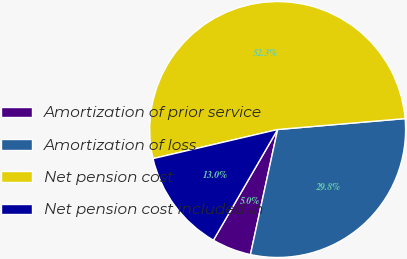<chart> <loc_0><loc_0><loc_500><loc_500><pie_chart><fcel>Amortization of prior service<fcel>Amortization of loss<fcel>Net pension cost<fcel>Net pension cost included in<nl><fcel>4.96%<fcel>29.77%<fcel>52.29%<fcel>12.98%<nl></chart> 